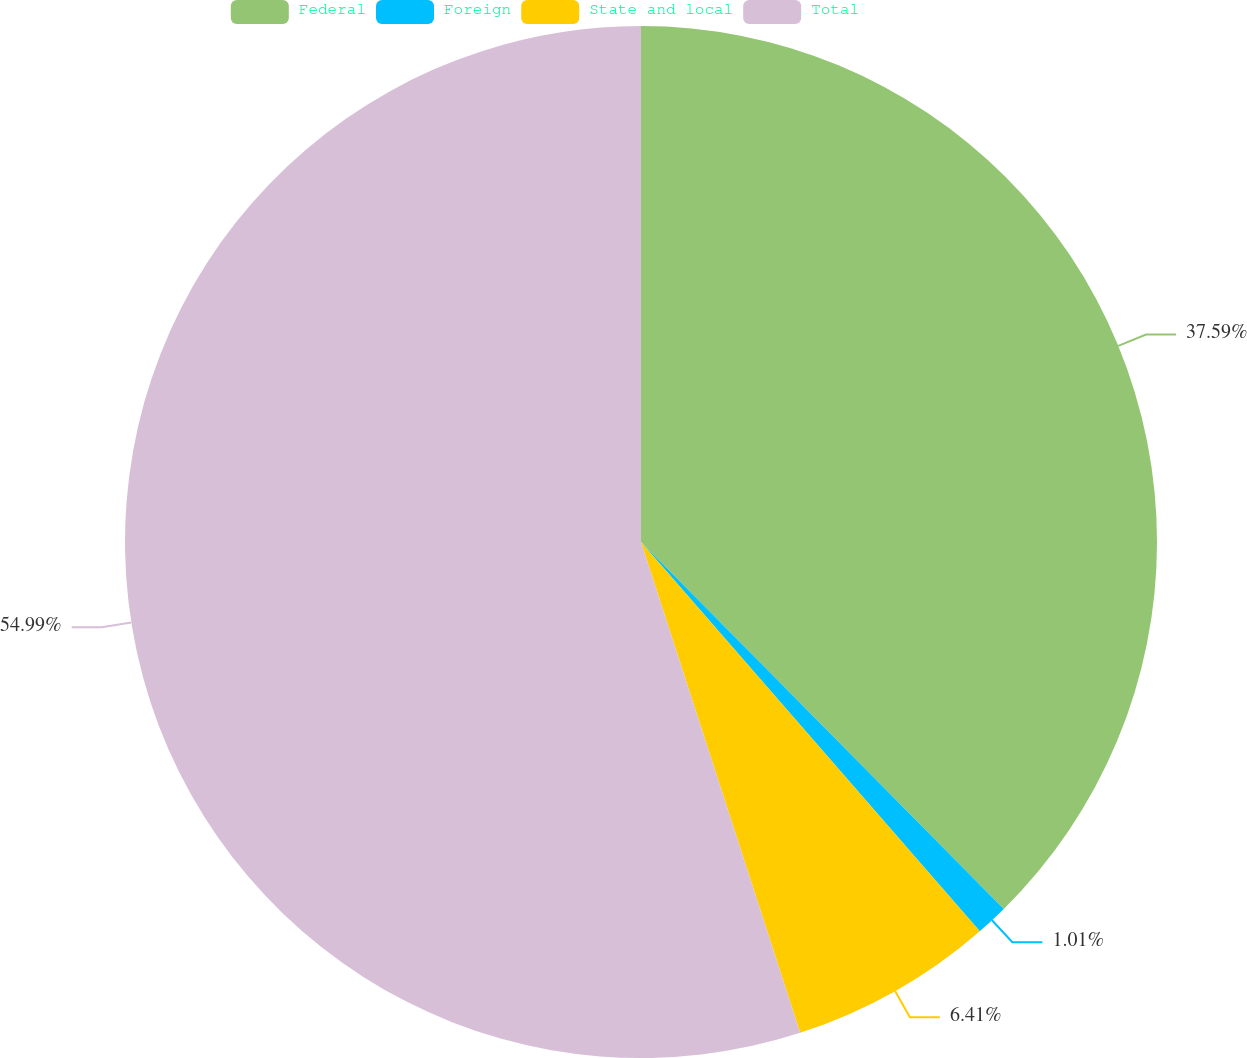Convert chart to OTSL. <chart><loc_0><loc_0><loc_500><loc_500><pie_chart><fcel>Federal<fcel>Foreign<fcel>State and local<fcel>Total<nl><fcel>37.59%<fcel>1.01%<fcel>6.41%<fcel>54.99%<nl></chart> 